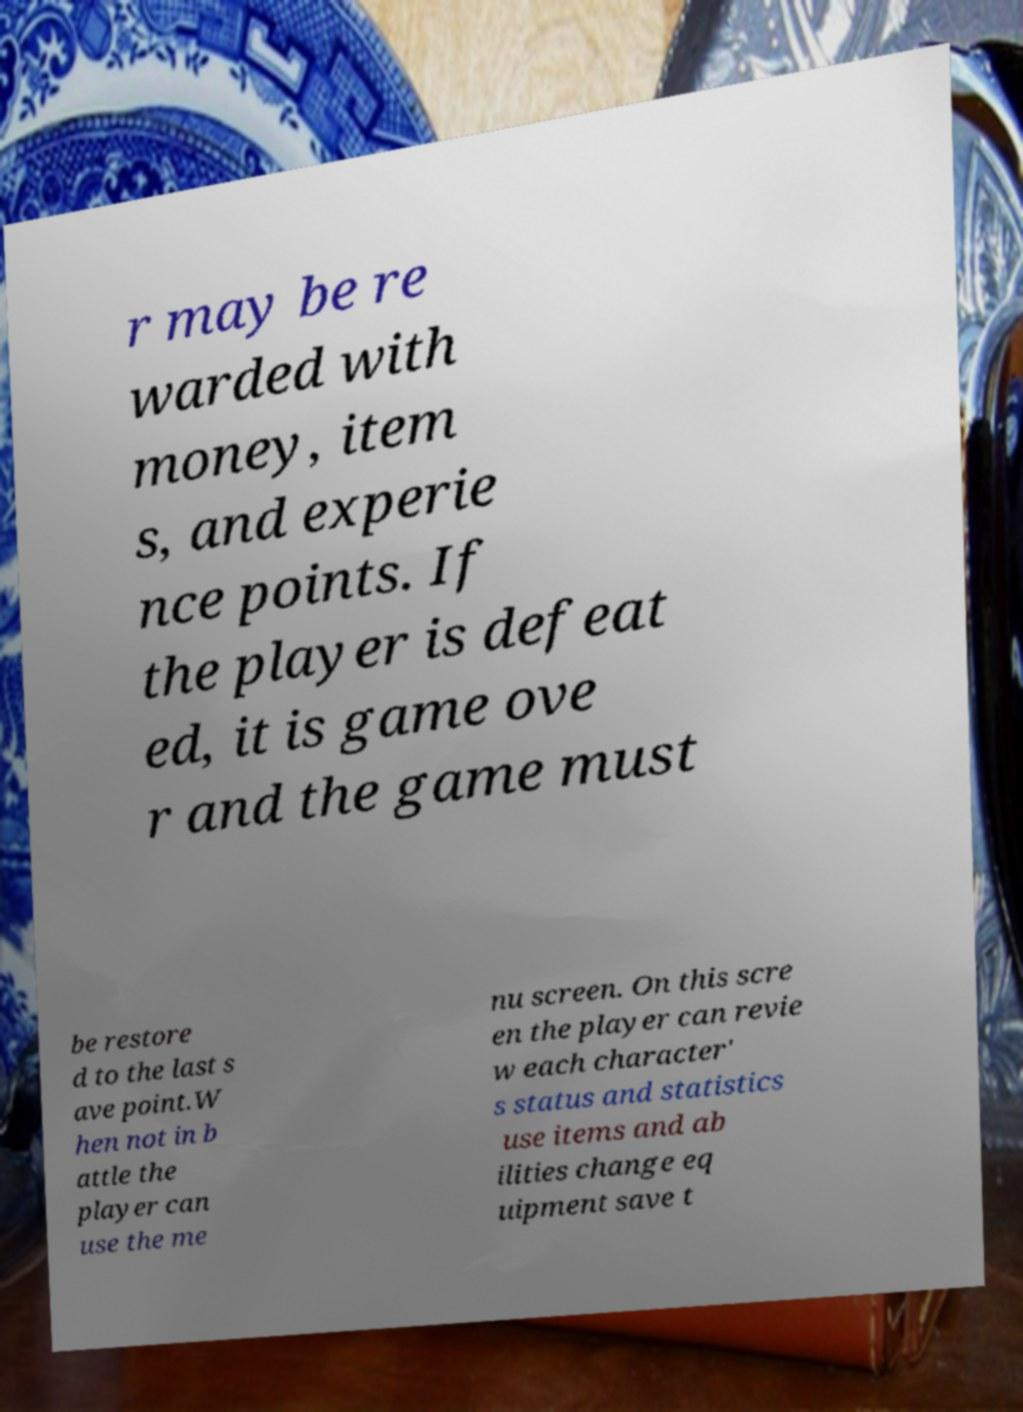There's text embedded in this image that I need extracted. Can you transcribe it verbatim? r may be re warded with money, item s, and experie nce points. If the player is defeat ed, it is game ove r and the game must be restore d to the last s ave point.W hen not in b attle the player can use the me nu screen. On this scre en the player can revie w each character' s status and statistics use items and ab ilities change eq uipment save t 